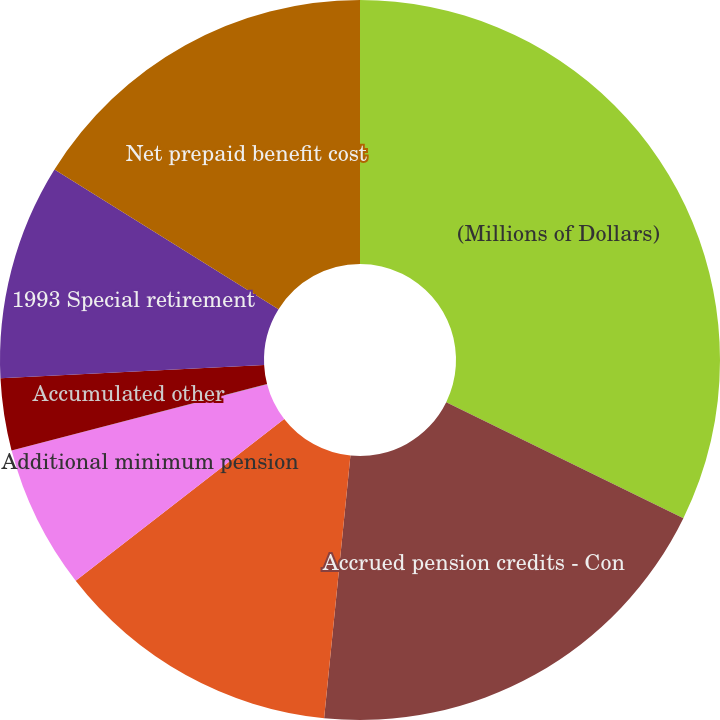<chart> <loc_0><loc_0><loc_500><loc_500><pie_chart><fcel>(Millions of Dollars)<fcel>Accrued pension credits - Con<fcel>Accrued benefit cost - O&R<fcel>Additional minimum pension<fcel>Intangible asset<fcel>Accumulated other<fcel>1993 Special retirement<fcel>Net prepaid benefit cost<nl><fcel>32.24%<fcel>19.35%<fcel>12.9%<fcel>6.46%<fcel>0.01%<fcel>3.23%<fcel>9.68%<fcel>16.13%<nl></chart> 